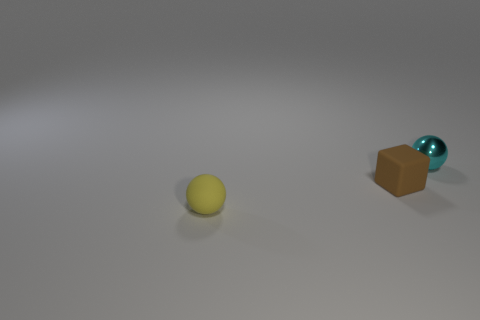What shape is the brown object?
Your answer should be compact. Cube. There is a small cyan object that is behind the ball that is on the left side of the tiny block; what shape is it?
Provide a succinct answer. Sphere. There is a object that is the same material as the brown block; what color is it?
Provide a short and direct response. Yellow. Is the number of tiny brown things that are in front of the tiny yellow matte ball greater than the number of cyan metal things on the right side of the tiny cyan shiny ball?
Ensure brevity in your answer.  No. What color is the other object that is the same shape as the yellow rubber thing?
Make the answer very short. Cyan. Is there any other thing that has the same shape as the brown matte object?
Make the answer very short. No. There is a yellow thing; is it the same shape as the small thing that is on the right side of the brown cube?
Provide a succinct answer. Yes. How many other things are made of the same material as the cyan sphere?
Provide a short and direct response. 0. There is a matte sphere; is its color the same as the tiny ball behind the rubber block?
Your answer should be compact. No. There is a tiny sphere that is in front of the cyan object; what is it made of?
Offer a very short reply. Rubber. 